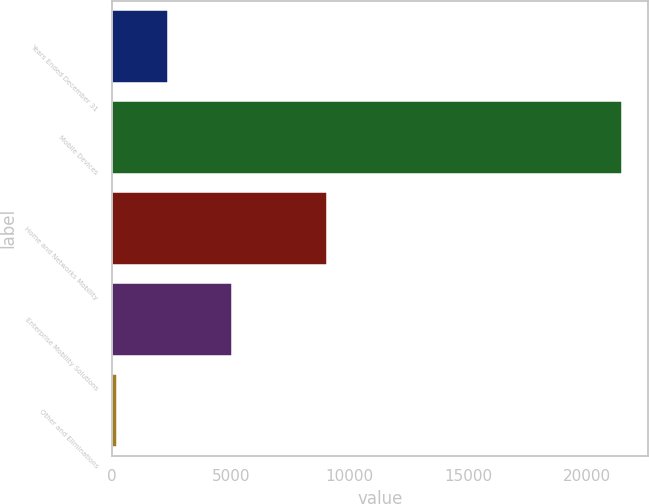<chart> <loc_0><loc_0><loc_500><loc_500><bar_chart><fcel>Years Ended December 31<fcel>Mobile Devices<fcel>Home and Networks Mobility<fcel>Enterprise Mobility Solutions<fcel>Other and Eliminations<nl><fcel>2347.5<fcel>21459<fcel>9037<fcel>5038<fcel>224<nl></chart> 